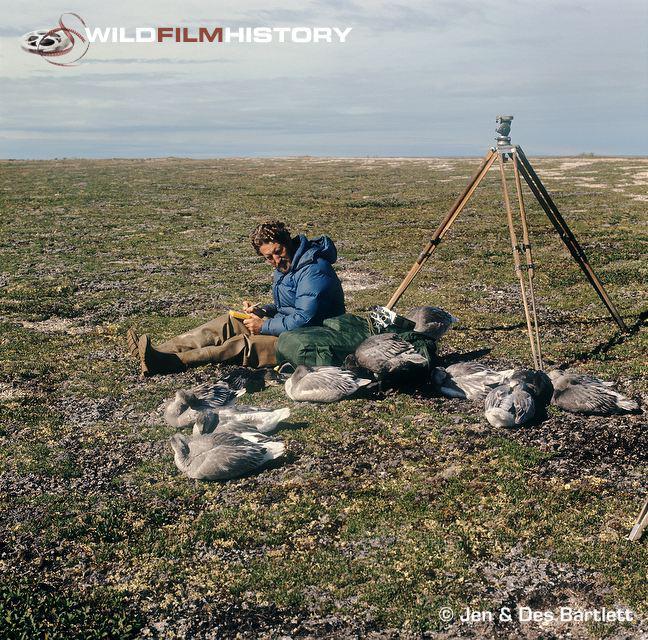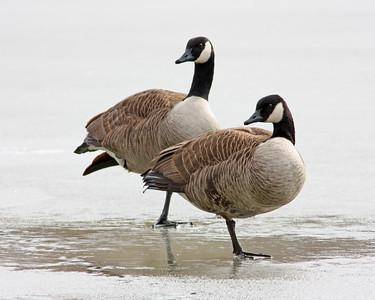The first image is the image on the left, the second image is the image on the right. Examine the images to the left and right. Is the description "The bird in the image on the right is sitting in the grass." accurate? Answer yes or no. No. The first image is the image on the left, the second image is the image on the right. Considering the images on both sides, is "There is a single geese in the foreground in each image." valid? Answer yes or no. No. 